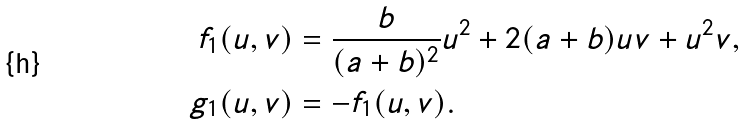Convert formula to latex. <formula><loc_0><loc_0><loc_500><loc_500>f _ { 1 } ( u , v ) & = \frac { b } { ( a + b ) ^ { 2 } } u ^ { 2 } + 2 ( a + b ) u v + u ^ { 2 } v , \\ g _ { 1 } ( u , v ) & = - f _ { 1 } ( u , v ) .</formula> 